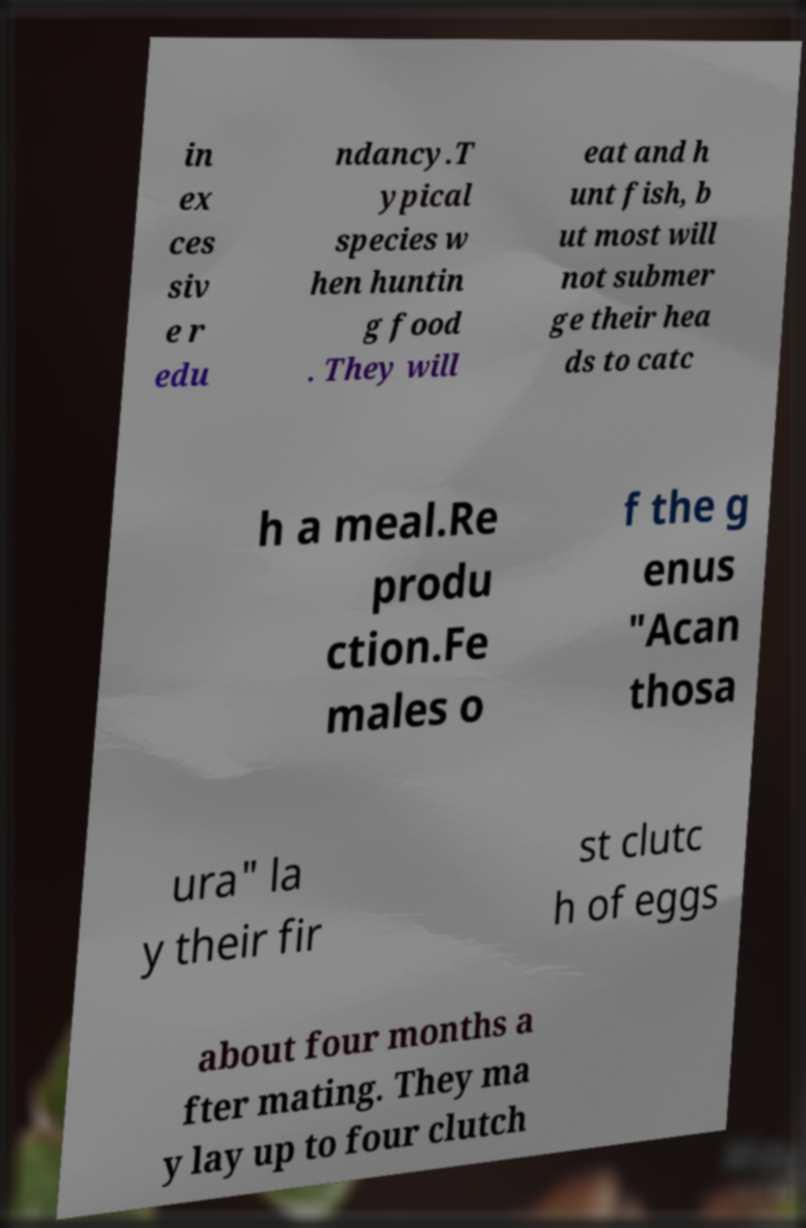For documentation purposes, I need the text within this image transcribed. Could you provide that? in ex ces siv e r edu ndancy.T ypical species w hen huntin g food . They will eat and h unt fish, b ut most will not submer ge their hea ds to catc h a meal.Re produ ction.Fe males o f the g enus "Acan thosa ura" la y their fir st clutc h of eggs about four months a fter mating. They ma y lay up to four clutch 